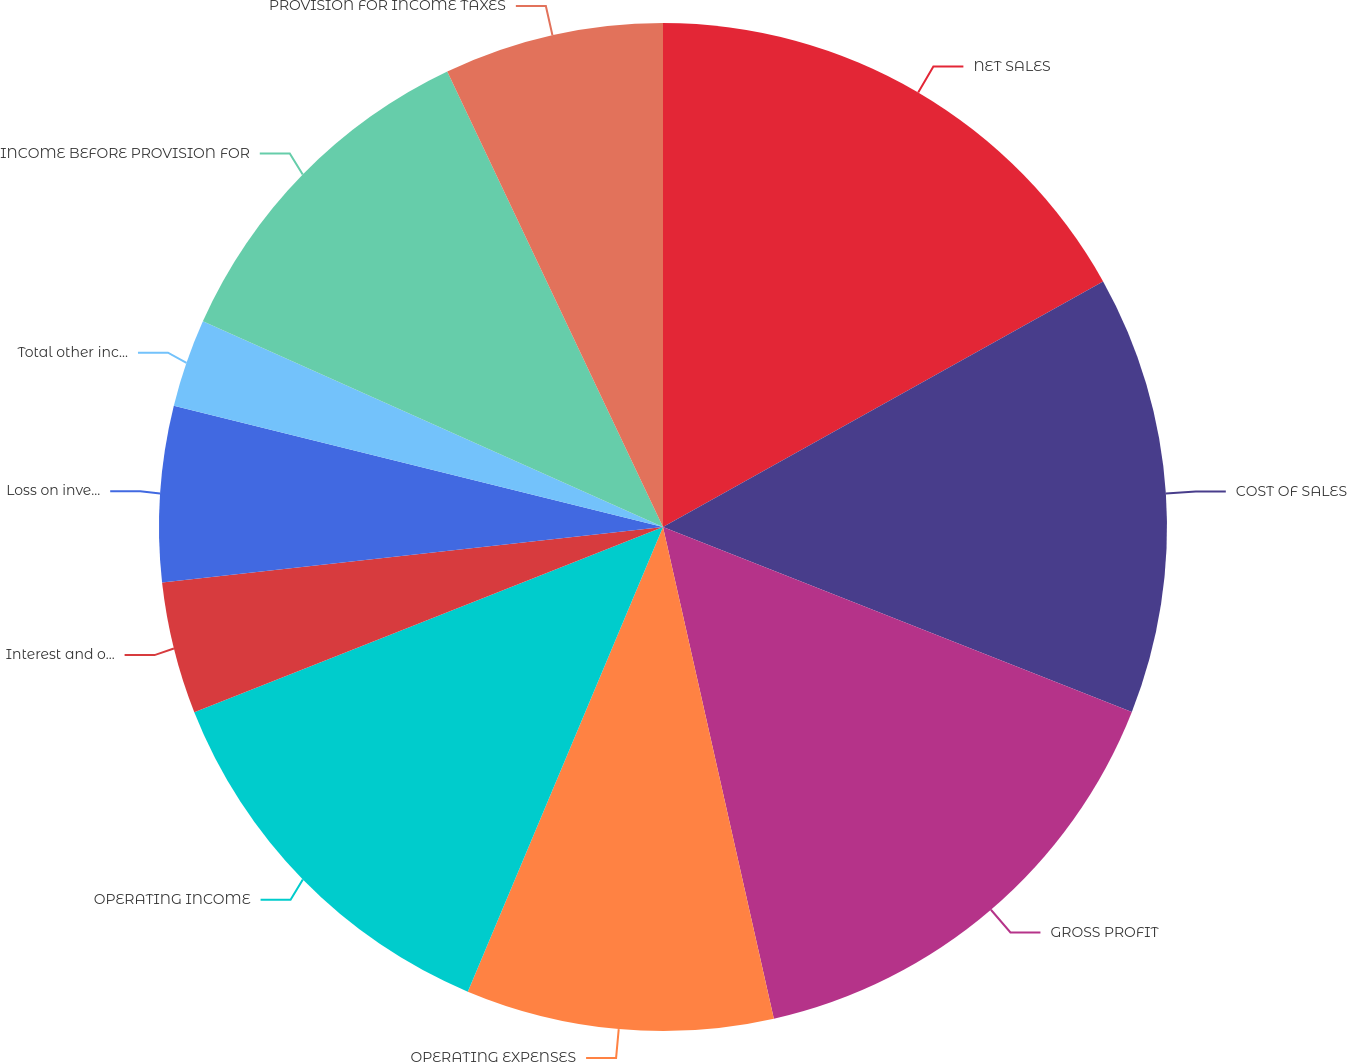Convert chart to OTSL. <chart><loc_0><loc_0><loc_500><loc_500><pie_chart><fcel>NET SALES<fcel>COST OF SALES<fcel>GROSS PROFIT<fcel>OPERATING EXPENSES<fcel>OPERATING INCOME<fcel>Interest and other income net<fcel>Loss on investments and put<fcel>Total other income (expense)<fcel>INCOME BEFORE PROVISION FOR<fcel>PROVISION FOR INCOME TAXES<nl><fcel>16.9%<fcel>14.08%<fcel>15.49%<fcel>9.86%<fcel>12.68%<fcel>4.23%<fcel>5.63%<fcel>2.82%<fcel>11.27%<fcel>7.04%<nl></chart> 